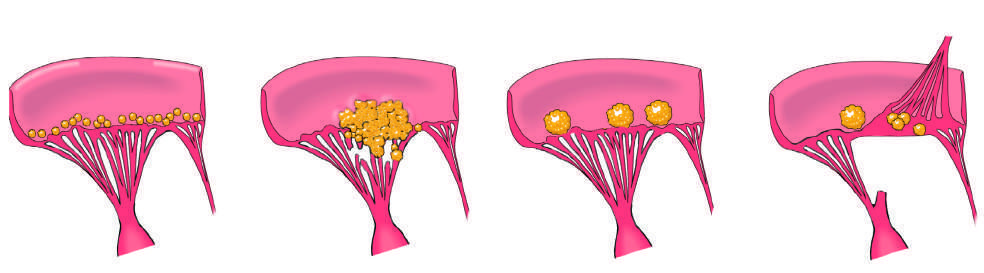do these heal with scarring?
Answer the question using a single word or phrase. Yes 